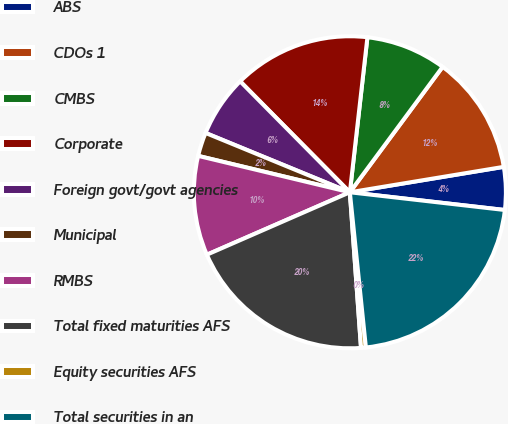<chart> <loc_0><loc_0><loc_500><loc_500><pie_chart><fcel>ABS<fcel>CDOs 1<fcel>CMBS<fcel>Corporate<fcel>Foreign govt/govt agencies<fcel>Municipal<fcel>RMBS<fcel>Total fixed maturities AFS<fcel>Equity securities AFS<fcel>Total securities in an<nl><fcel>4.42%<fcel>12.26%<fcel>8.34%<fcel>14.21%<fcel>6.38%<fcel>2.46%<fcel>10.3%<fcel>19.59%<fcel>0.5%<fcel>21.55%<nl></chart> 